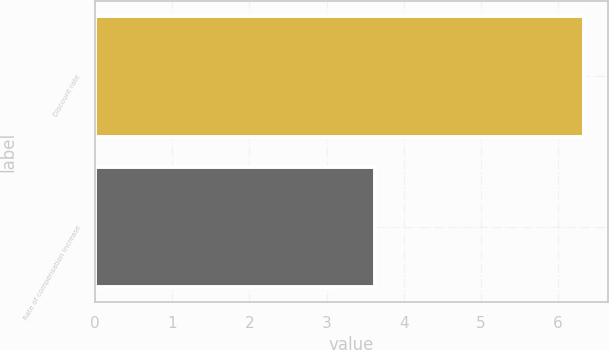Convert chart. <chart><loc_0><loc_0><loc_500><loc_500><bar_chart><fcel>Discount rate<fcel>Rate of compensation increase<nl><fcel>6.33<fcel>3.63<nl></chart> 